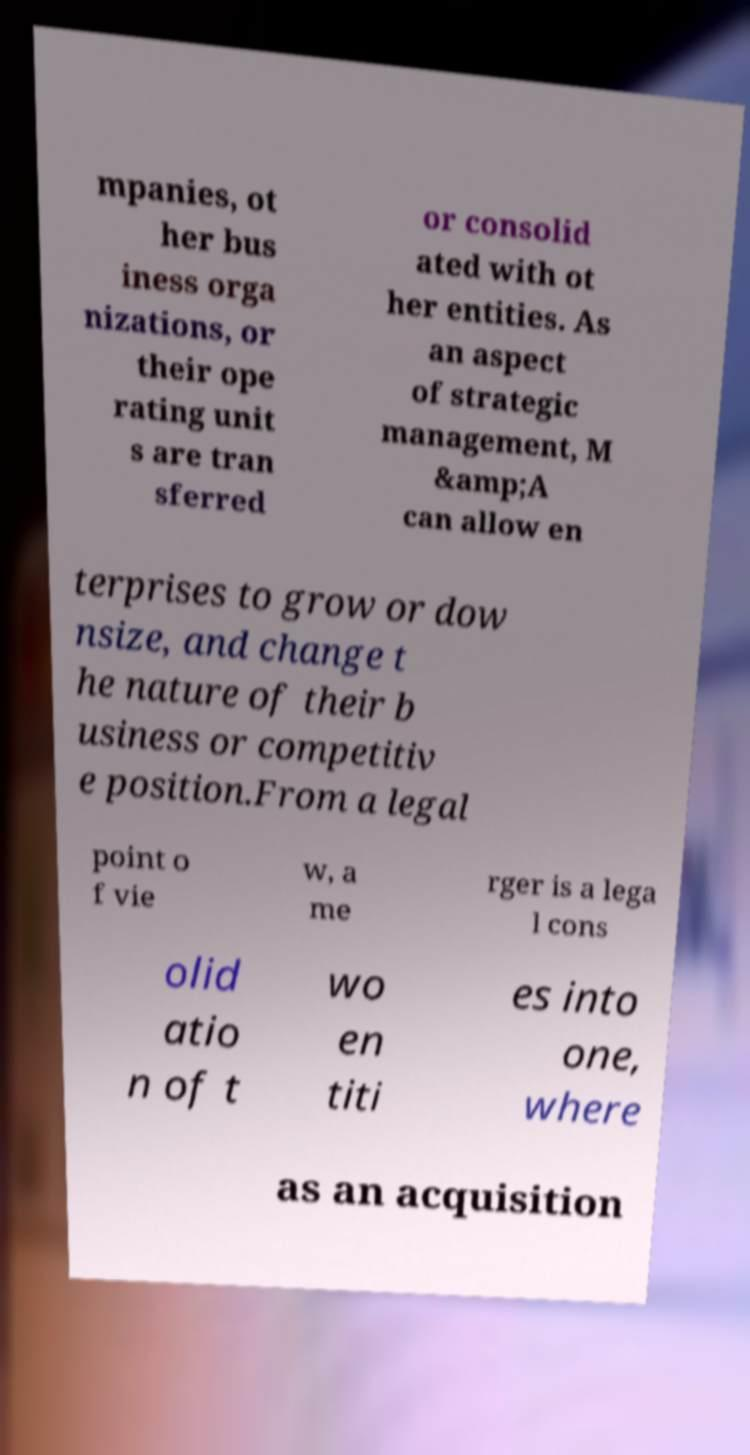Please identify and transcribe the text found in this image. mpanies, ot her bus iness orga nizations, or their ope rating unit s are tran sferred or consolid ated with ot her entities. As an aspect of strategic management, M &amp;A can allow en terprises to grow or dow nsize, and change t he nature of their b usiness or competitiv e position.From a legal point o f vie w, a me rger is a lega l cons olid atio n of t wo en titi es into one, where as an acquisition 